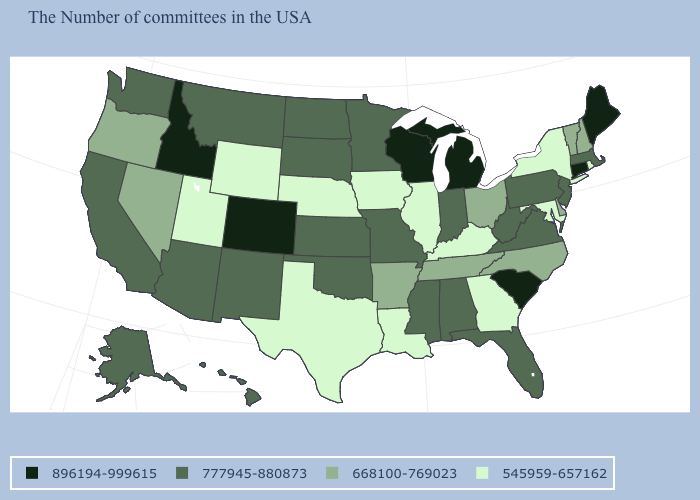Among the states that border Pennsylvania , which have the lowest value?
Quick response, please. New York, Maryland. What is the value of Maine?
Quick response, please. 896194-999615. What is the value of Maryland?
Answer briefly. 545959-657162. What is the value of Arizona?
Concise answer only. 777945-880873. Name the states that have a value in the range 896194-999615?
Answer briefly. Maine, Connecticut, South Carolina, Michigan, Wisconsin, Colorado, Idaho. Does Massachusetts have a higher value than Wyoming?
Quick response, please. Yes. Name the states that have a value in the range 668100-769023?
Concise answer only. New Hampshire, Vermont, Delaware, North Carolina, Ohio, Tennessee, Arkansas, Nevada, Oregon. Does Illinois have the lowest value in the MidWest?
Give a very brief answer. Yes. What is the value of Oregon?
Give a very brief answer. 668100-769023. What is the value of Florida?
Answer briefly. 777945-880873. What is the lowest value in states that border Rhode Island?
Answer briefly. 777945-880873. What is the highest value in states that border Tennessee?
Give a very brief answer. 777945-880873. Name the states that have a value in the range 668100-769023?
Concise answer only. New Hampshire, Vermont, Delaware, North Carolina, Ohio, Tennessee, Arkansas, Nevada, Oregon. Which states hav the highest value in the West?
Short answer required. Colorado, Idaho. Does the first symbol in the legend represent the smallest category?
Give a very brief answer. No. 